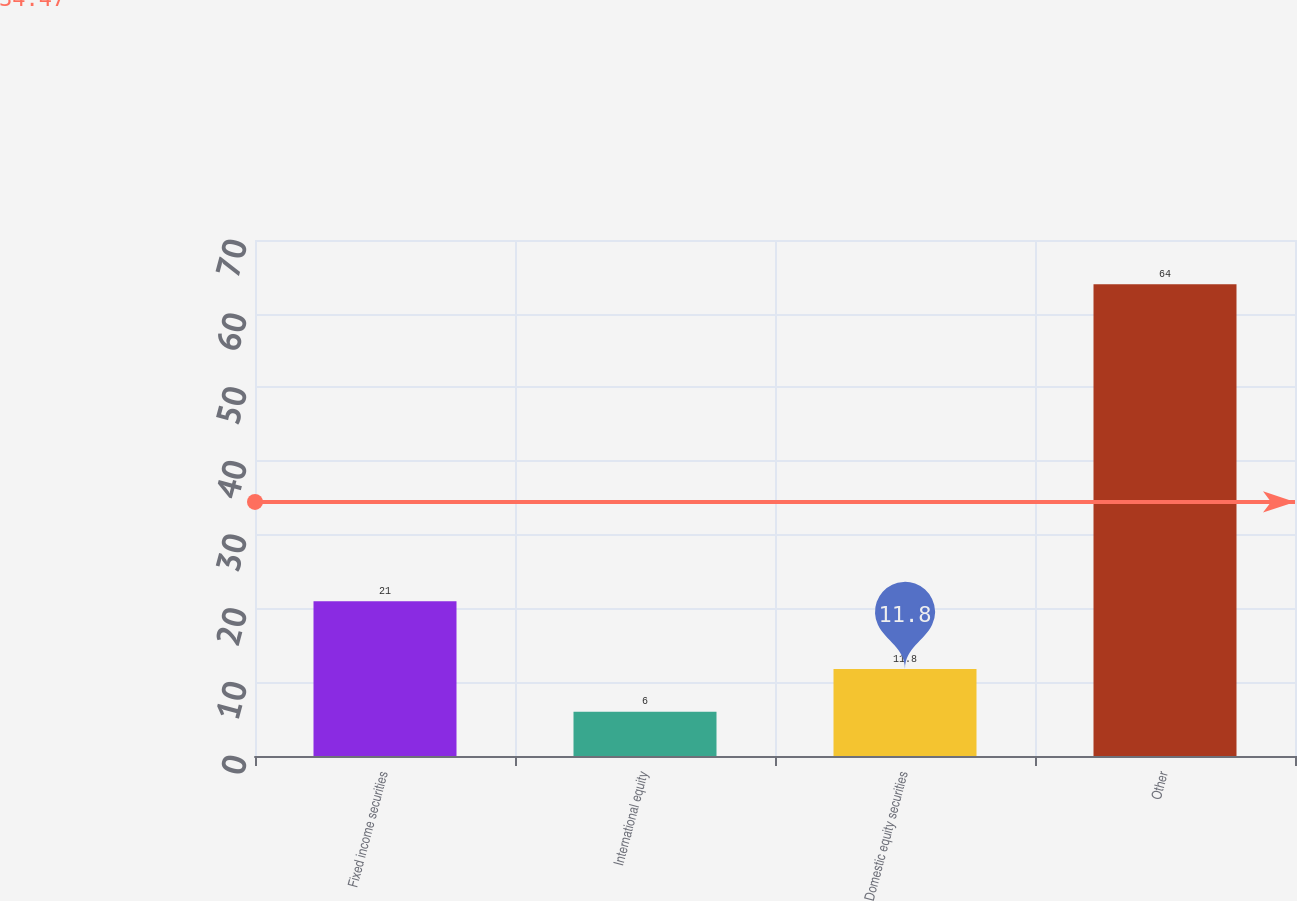<chart> <loc_0><loc_0><loc_500><loc_500><bar_chart><fcel>Fixed income securities<fcel>International equity<fcel>Domestic equity securities<fcel>Other<nl><fcel>21<fcel>6<fcel>11.8<fcel>64<nl></chart> 